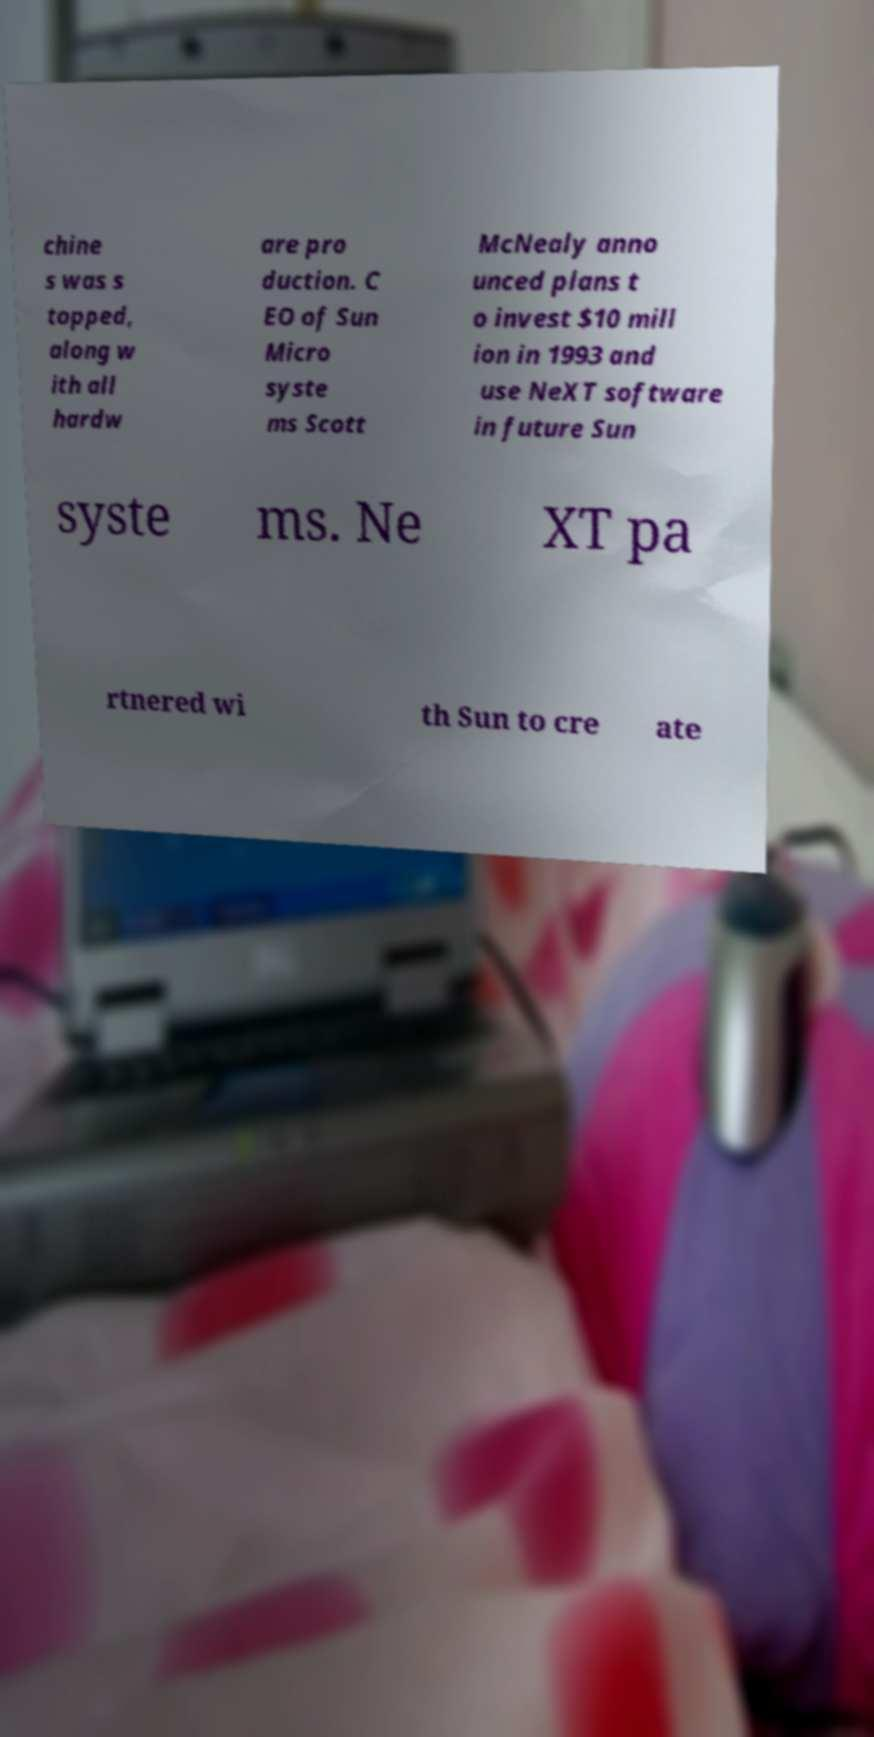Can you accurately transcribe the text from the provided image for me? chine s was s topped, along w ith all hardw are pro duction. C EO of Sun Micro syste ms Scott McNealy anno unced plans t o invest $10 mill ion in 1993 and use NeXT software in future Sun syste ms. Ne XT pa rtnered wi th Sun to cre ate 